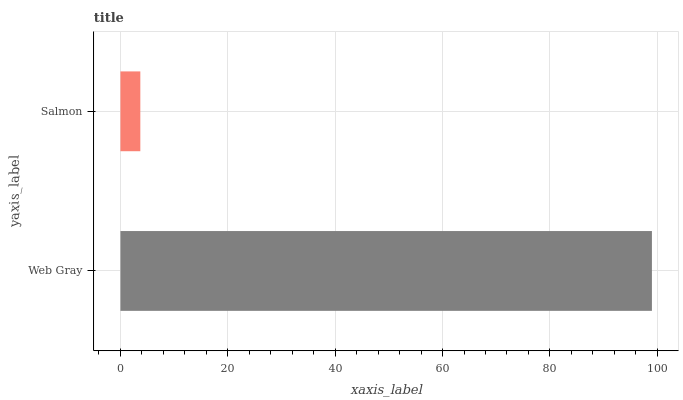Is Salmon the minimum?
Answer yes or no. Yes. Is Web Gray the maximum?
Answer yes or no. Yes. Is Salmon the maximum?
Answer yes or no. No. Is Web Gray greater than Salmon?
Answer yes or no. Yes. Is Salmon less than Web Gray?
Answer yes or no. Yes. Is Salmon greater than Web Gray?
Answer yes or no. No. Is Web Gray less than Salmon?
Answer yes or no. No. Is Web Gray the high median?
Answer yes or no. Yes. Is Salmon the low median?
Answer yes or no. Yes. Is Salmon the high median?
Answer yes or no. No. Is Web Gray the low median?
Answer yes or no. No. 